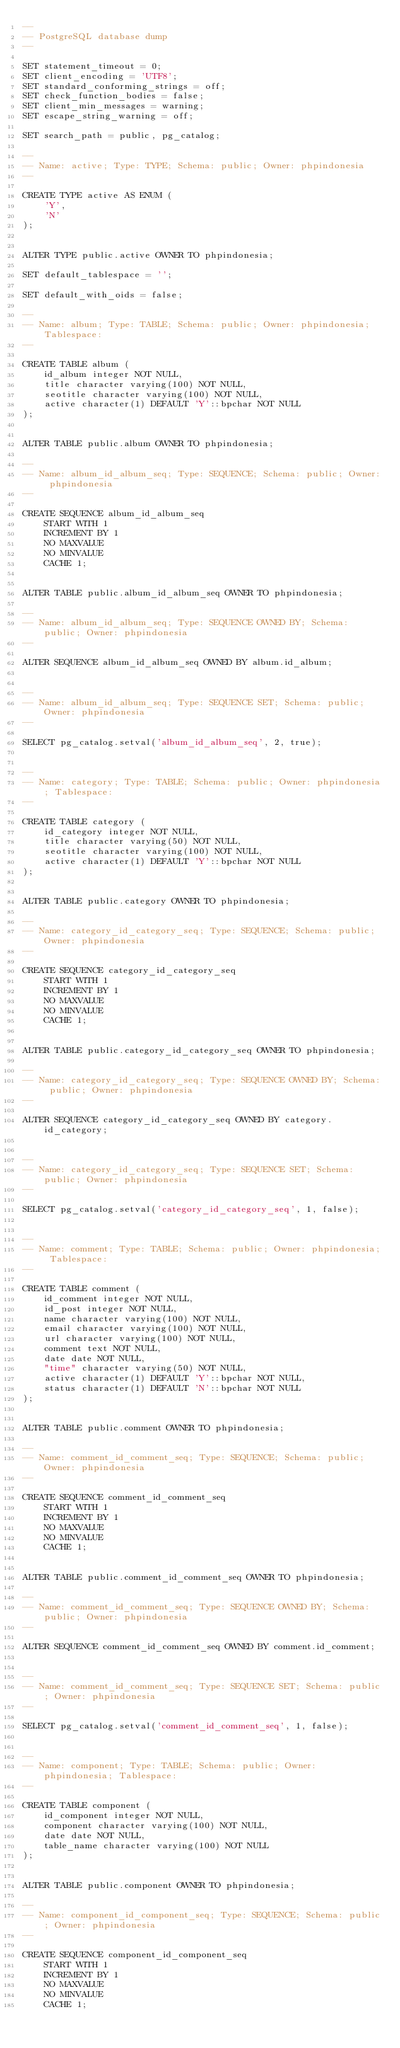Convert code to text. <code><loc_0><loc_0><loc_500><loc_500><_SQL_>--
-- PostgreSQL database dump
--

SET statement_timeout = 0;
SET client_encoding = 'UTF8';
SET standard_conforming_strings = off;
SET check_function_bodies = false;
SET client_min_messages = warning;
SET escape_string_warning = off;

SET search_path = public, pg_catalog;

--
-- Name: active; Type: TYPE; Schema: public; Owner: phpindonesia
--

CREATE TYPE active AS ENUM (
    'Y',
    'N'
);


ALTER TYPE public.active OWNER TO phpindonesia;

SET default_tablespace = '';

SET default_with_oids = false;

--
-- Name: album; Type: TABLE; Schema: public; Owner: phpindonesia; Tablespace: 
--

CREATE TABLE album (
    id_album integer NOT NULL,
    title character varying(100) NOT NULL,
    seotitle character varying(100) NOT NULL,
    active character(1) DEFAULT 'Y'::bpchar NOT NULL
);


ALTER TABLE public.album OWNER TO phpindonesia;

--
-- Name: album_id_album_seq; Type: SEQUENCE; Schema: public; Owner: phpindonesia
--

CREATE SEQUENCE album_id_album_seq
    START WITH 1
    INCREMENT BY 1
    NO MAXVALUE
    NO MINVALUE
    CACHE 1;


ALTER TABLE public.album_id_album_seq OWNER TO phpindonesia;

--
-- Name: album_id_album_seq; Type: SEQUENCE OWNED BY; Schema: public; Owner: phpindonesia
--

ALTER SEQUENCE album_id_album_seq OWNED BY album.id_album;


--
-- Name: album_id_album_seq; Type: SEQUENCE SET; Schema: public; Owner: phpindonesia
--

SELECT pg_catalog.setval('album_id_album_seq', 2, true);


--
-- Name: category; Type: TABLE; Schema: public; Owner: phpindonesia; Tablespace: 
--

CREATE TABLE category (
    id_category integer NOT NULL,
    title character varying(50) NOT NULL,
    seotitle character varying(100) NOT NULL,
    active character(1) DEFAULT 'Y'::bpchar NOT NULL
);


ALTER TABLE public.category OWNER TO phpindonesia;

--
-- Name: category_id_category_seq; Type: SEQUENCE; Schema: public; Owner: phpindonesia
--

CREATE SEQUENCE category_id_category_seq
    START WITH 1
    INCREMENT BY 1
    NO MAXVALUE
    NO MINVALUE
    CACHE 1;


ALTER TABLE public.category_id_category_seq OWNER TO phpindonesia;

--
-- Name: category_id_category_seq; Type: SEQUENCE OWNED BY; Schema: public; Owner: phpindonesia
--

ALTER SEQUENCE category_id_category_seq OWNED BY category.id_category;


--
-- Name: category_id_category_seq; Type: SEQUENCE SET; Schema: public; Owner: phpindonesia
--

SELECT pg_catalog.setval('category_id_category_seq', 1, false);


--
-- Name: comment; Type: TABLE; Schema: public; Owner: phpindonesia; Tablespace: 
--

CREATE TABLE comment (
    id_comment integer NOT NULL,
    id_post integer NOT NULL,
    name character varying(100) NOT NULL,
    email character varying(100) NOT NULL,
    url character varying(100) NOT NULL,
    comment text NOT NULL,
    date date NOT NULL,
    "time" character varying(50) NOT NULL,
    active character(1) DEFAULT 'Y'::bpchar NOT NULL,
    status character(1) DEFAULT 'N'::bpchar NOT NULL
);


ALTER TABLE public.comment OWNER TO phpindonesia;

--
-- Name: comment_id_comment_seq; Type: SEQUENCE; Schema: public; Owner: phpindonesia
--

CREATE SEQUENCE comment_id_comment_seq
    START WITH 1
    INCREMENT BY 1
    NO MAXVALUE
    NO MINVALUE
    CACHE 1;


ALTER TABLE public.comment_id_comment_seq OWNER TO phpindonesia;

--
-- Name: comment_id_comment_seq; Type: SEQUENCE OWNED BY; Schema: public; Owner: phpindonesia
--

ALTER SEQUENCE comment_id_comment_seq OWNED BY comment.id_comment;


--
-- Name: comment_id_comment_seq; Type: SEQUENCE SET; Schema: public; Owner: phpindonesia
--

SELECT pg_catalog.setval('comment_id_comment_seq', 1, false);


--
-- Name: component; Type: TABLE; Schema: public; Owner: phpindonesia; Tablespace: 
--

CREATE TABLE component (
    id_component integer NOT NULL,
    component character varying(100) NOT NULL,
    date date NOT NULL,
    table_name character varying(100) NOT NULL
);


ALTER TABLE public.component OWNER TO phpindonesia;

--
-- Name: component_id_component_seq; Type: SEQUENCE; Schema: public; Owner: phpindonesia
--

CREATE SEQUENCE component_id_component_seq
    START WITH 1
    INCREMENT BY 1
    NO MAXVALUE
    NO MINVALUE
    CACHE 1;

</code> 